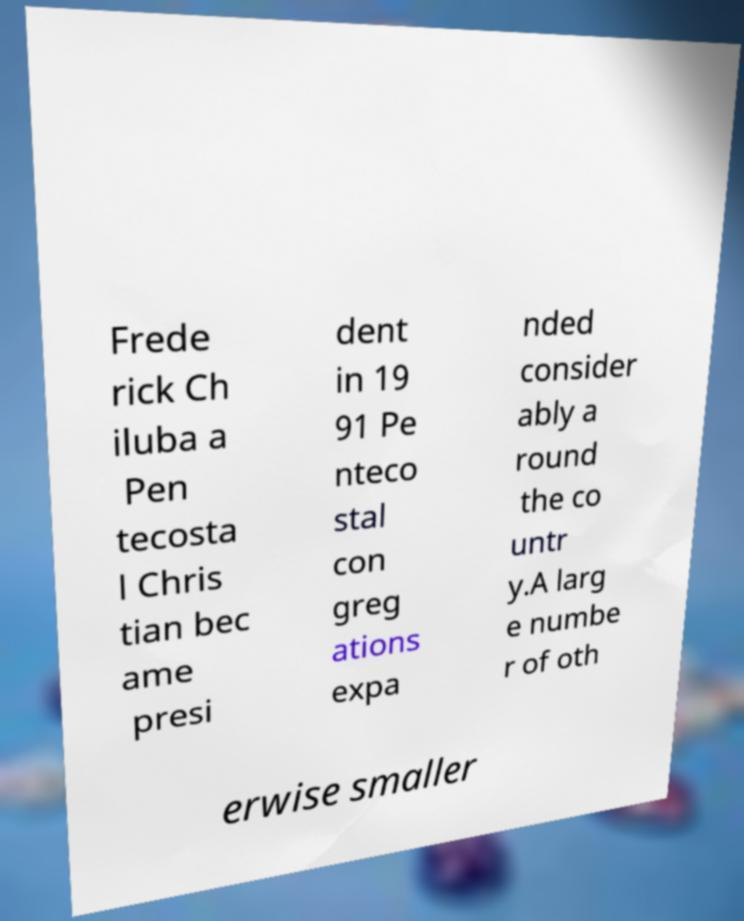Please read and relay the text visible in this image. What does it say? Frede rick Ch iluba a Pen tecosta l Chris tian bec ame presi dent in 19 91 Pe nteco stal con greg ations expa nded consider ably a round the co untr y.A larg e numbe r of oth erwise smaller 